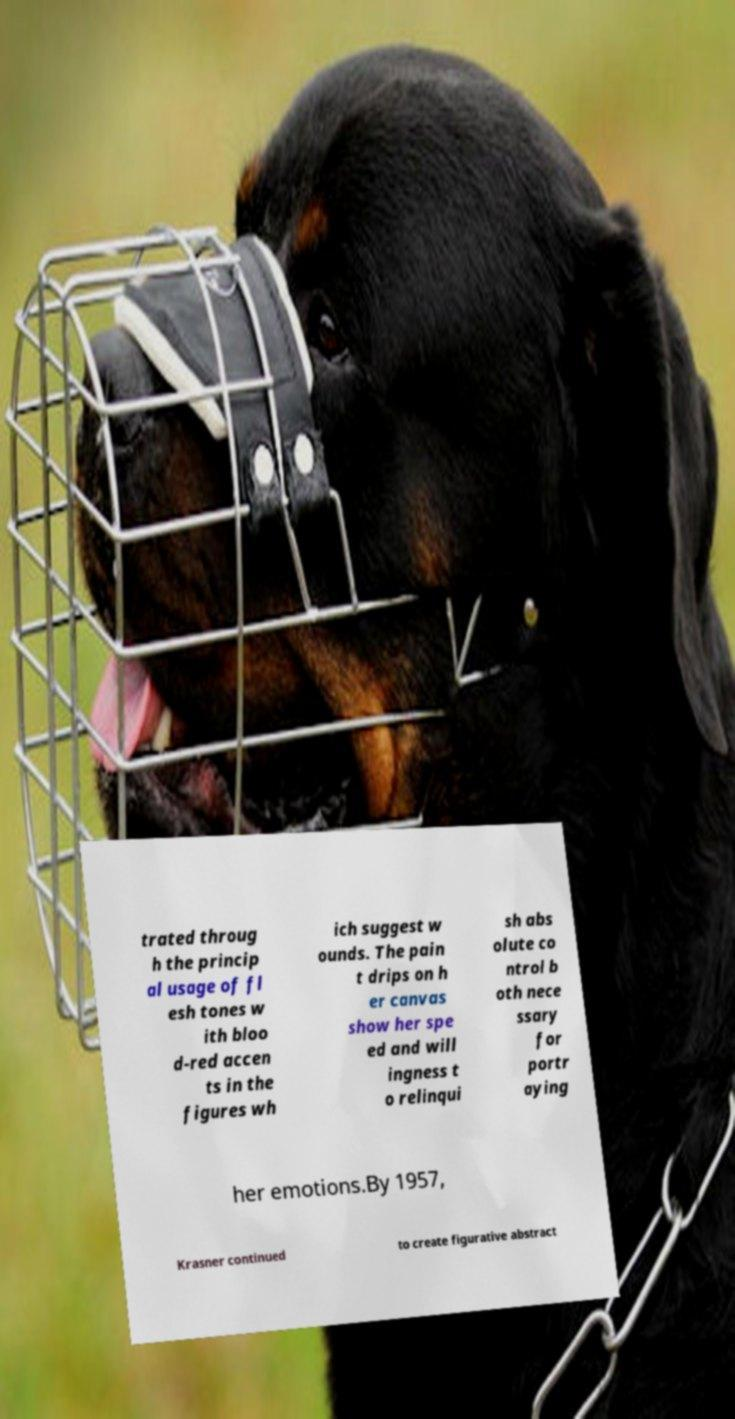Can you read and provide the text displayed in the image?This photo seems to have some interesting text. Can you extract and type it out for me? trated throug h the princip al usage of fl esh tones w ith bloo d-red accen ts in the figures wh ich suggest w ounds. The pain t drips on h er canvas show her spe ed and will ingness t o relinqui sh abs olute co ntrol b oth nece ssary for portr aying her emotions.By 1957, Krasner continued to create figurative abstract 